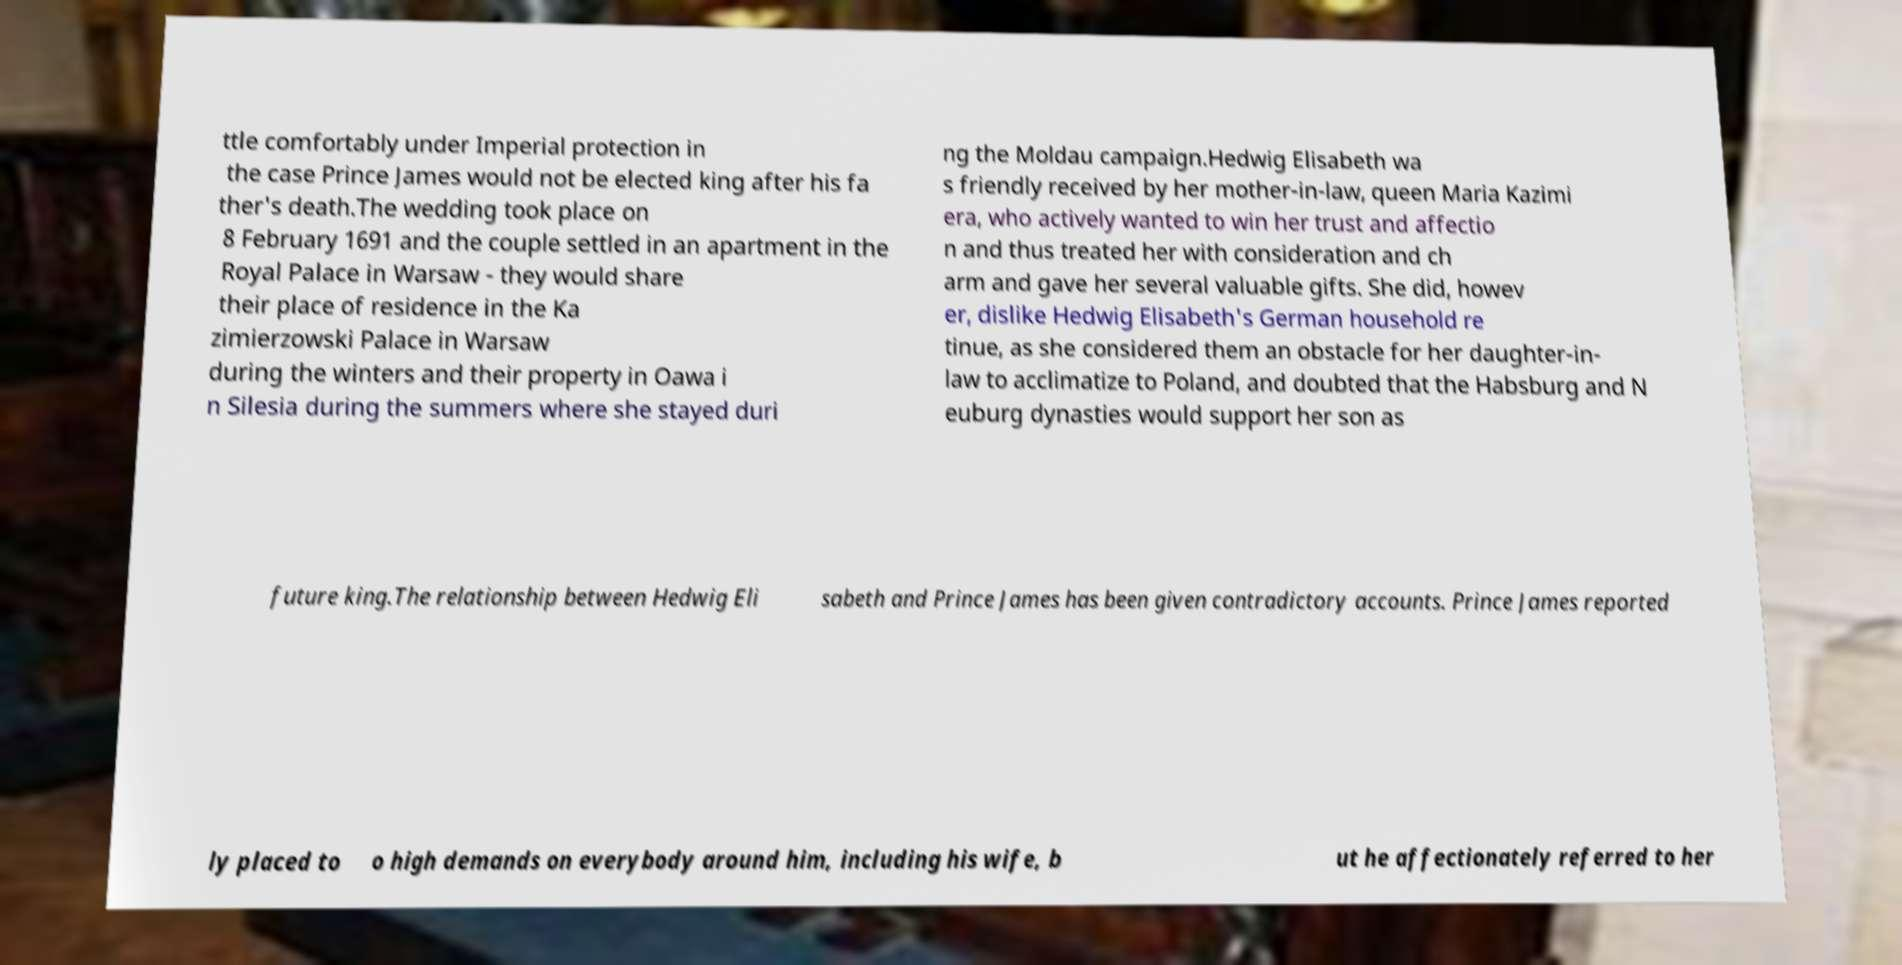Could you extract and type out the text from this image? ttle comfortably under Imperial protection in the case Prince James would not be elected king after his fa ther's death.The wedding took place on 8 February 1691 and the couple settled in an apartment in the Royal Palace in Warsaw - they would share their place of residence in the Ka zimierzowski Palace in Warsaw during the winters and their property in Oawa i n Silesia during the summers where she stayed duri ng the Moldau campaign.Hedwig Elisabeth wa s friendly received by her mother-in-law, queen Maria Kazimi era, who actively wanted to win her trust and affectio n and thus treated her with consideration and ch arm and gave her several valuable gifts. She did, howev er, dislike Hedwig Elisabeth's German household re tinue, as she considered them an obstacle for her daughter-in- law to acclimatize to Poland, and doubted that the Habsburg and N euburg dynasties would support her son as future king.The relationship between Hedwig Eli sabeth and Prince James has been given contradictory accounts. Prince James reported ly placed to o high demands on everybody around him, including his wife, b ut he affectionately referred to her 